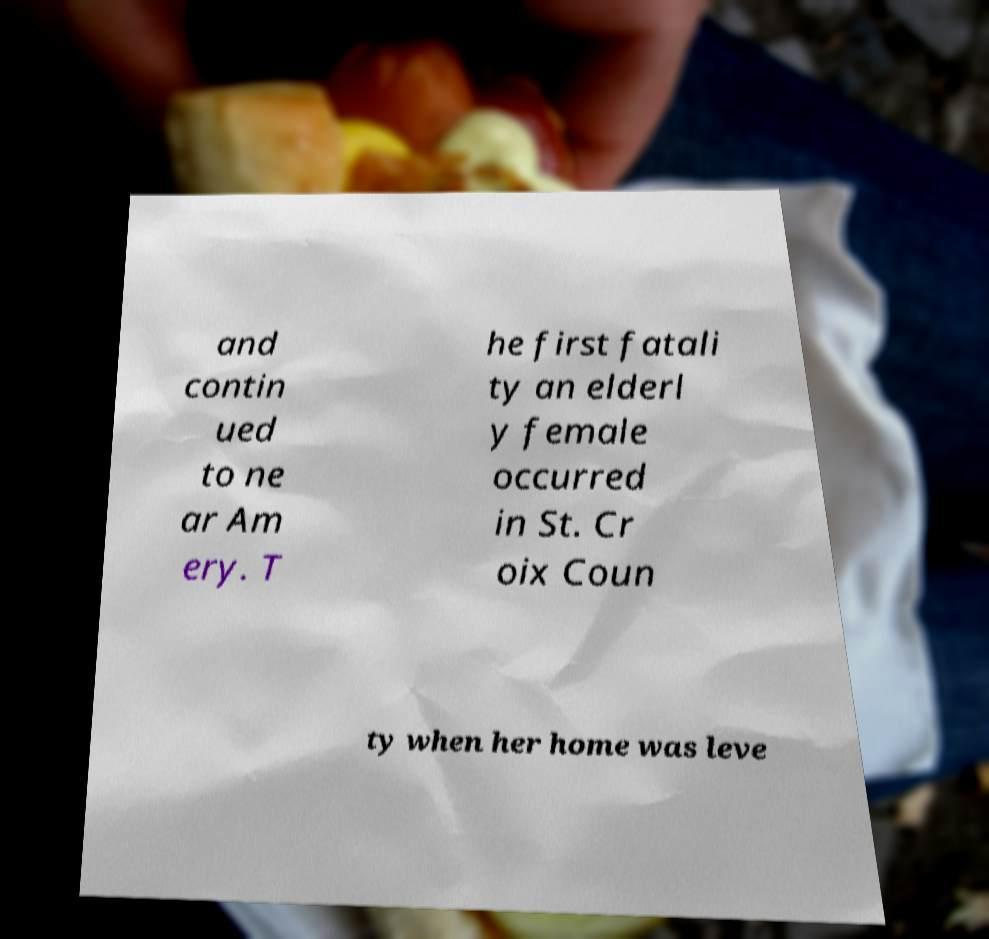There's text embedded in this image that I need extracted. Can you transcribe it verbatim? and contin ued to ne ar Am ery. T he first fatali ty an elderl y female occurred in St. Cr oix Coun ty when her home was leve 